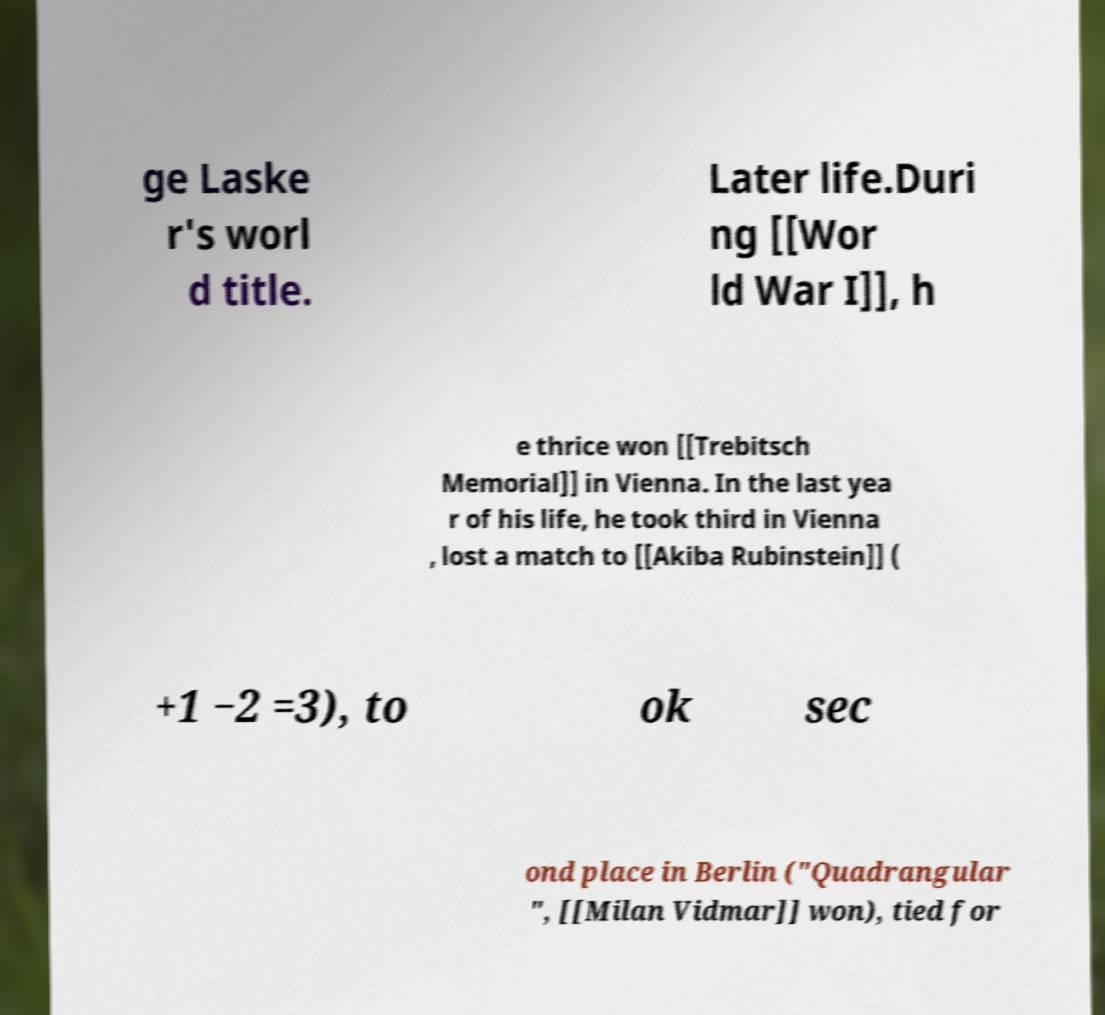Can you accurately transcribe the text from the provided image for me? ge Laske r's worl d title. Later life.Duri ng [[Wor ld War I]], h e thrice won [[Trebitsch Memorial]] in Vienna. In the last yea r of his life, he took third in Vienna , lost a match to [[Akiba Rubinstein]] ( +1 −2 =3), to ok sec ond place in Berlin ("Quadrangular ", [[Milan Vidmar]] won), tied for 